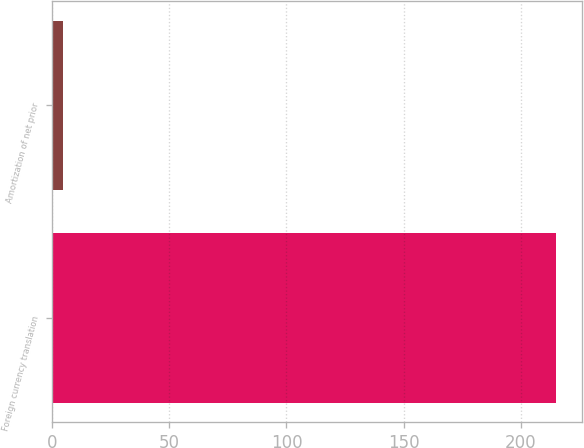Convert chart to OTSL. <chart><loc_0><loc_0><loc_500><loc_500><bar_chart><fcel>Foreign currency translation<fcel>Amortization of net prior<nl><fcel>215.2<fcel>4.6<nl></chart> 